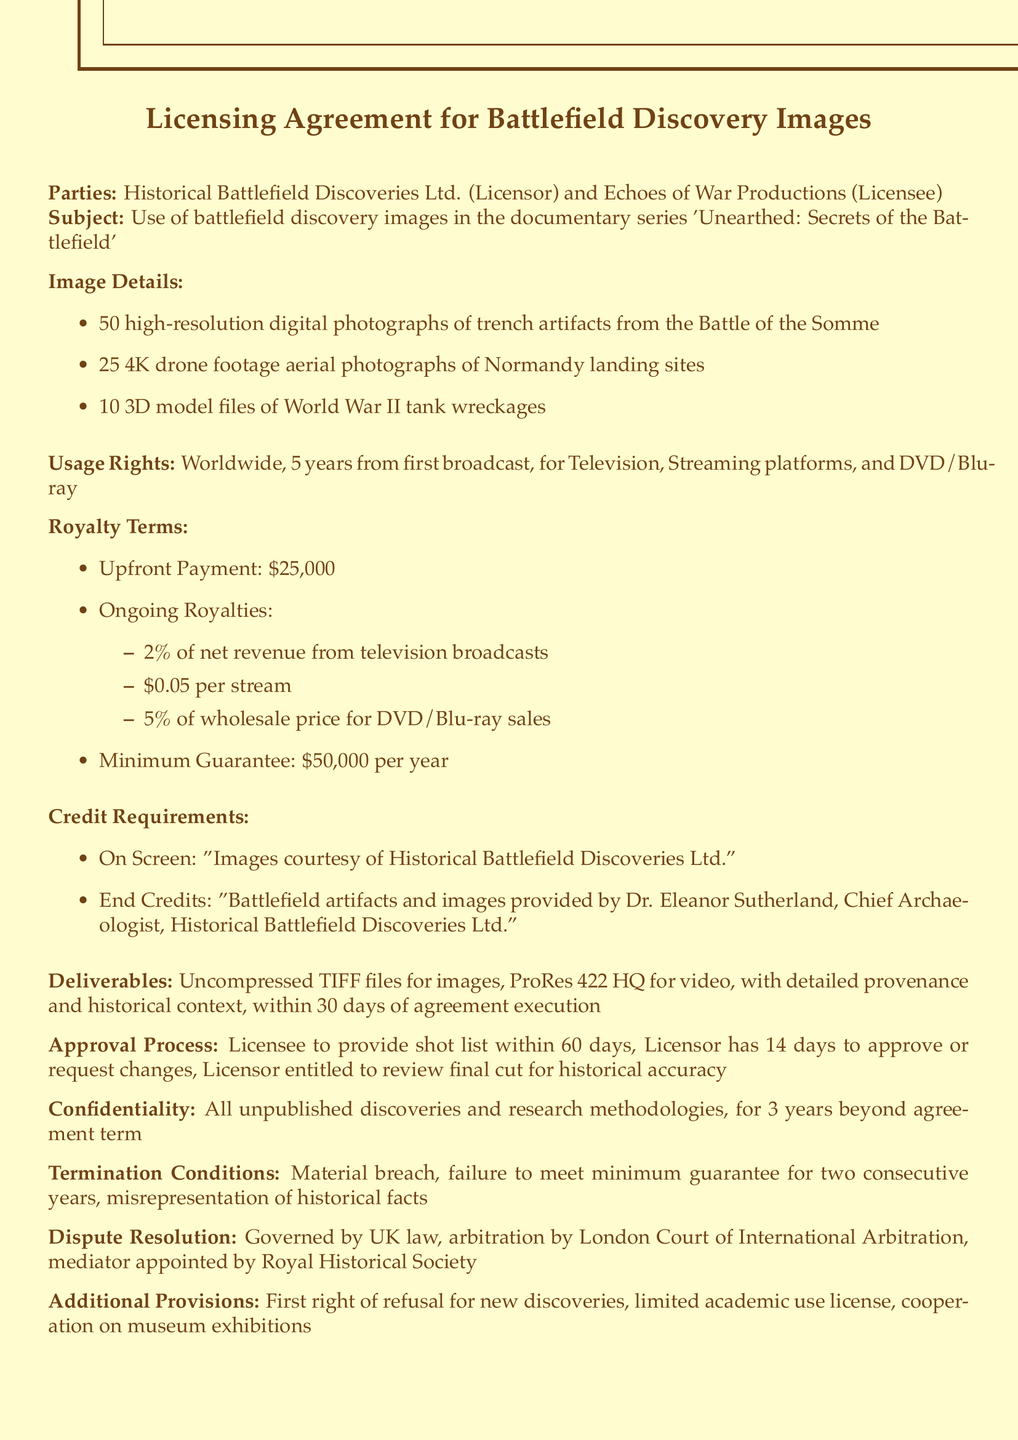What is the name of the licensor? The licensor's name is specified as Historical Battlefield Discoveries Ltd.
Answer: Historical Battlefield Discoveries Ltd How many aerial photographs are included? The document states that there are 25 aerial photographs of Normandy landing sites.
Answer: 25 What is the duration of the usage rights? The agreement specifies a duration of 5 years from the date of the first broadcast.
Answer: 5 years What is the upfront payment amount? The upfront payment is clearly stated as $25,000 in the royalty terms section.
Answer: $25,000 What is the royalty percentage for television broadcasts? The agreement specifies a 2% royalty on net revenue from television broadcasts.
Answer: 2% What happens if the minimum guarantee is not met for two consecutive years? The document outlines that failure to meet the minimum guarantee for two consecutive years can be a termination condition.
Answer: Termination Who is the chief archaeologist mentioned in the credits? The name of the chief archaeologist is provided as Dr. Eleanor Sutherland.
Answer: Dr. Eleanor Sutherland What is the governing law for dispute resolution? The governing law for any disputes is specified as the Laws of the United Kingdom.
Answer: Laws of the United Kingdom What type of files are to be delivered for images? The document specifies that uncompressed TIFF files are the required format for image deliverables.
Answer: Uncompressed TIFF files 